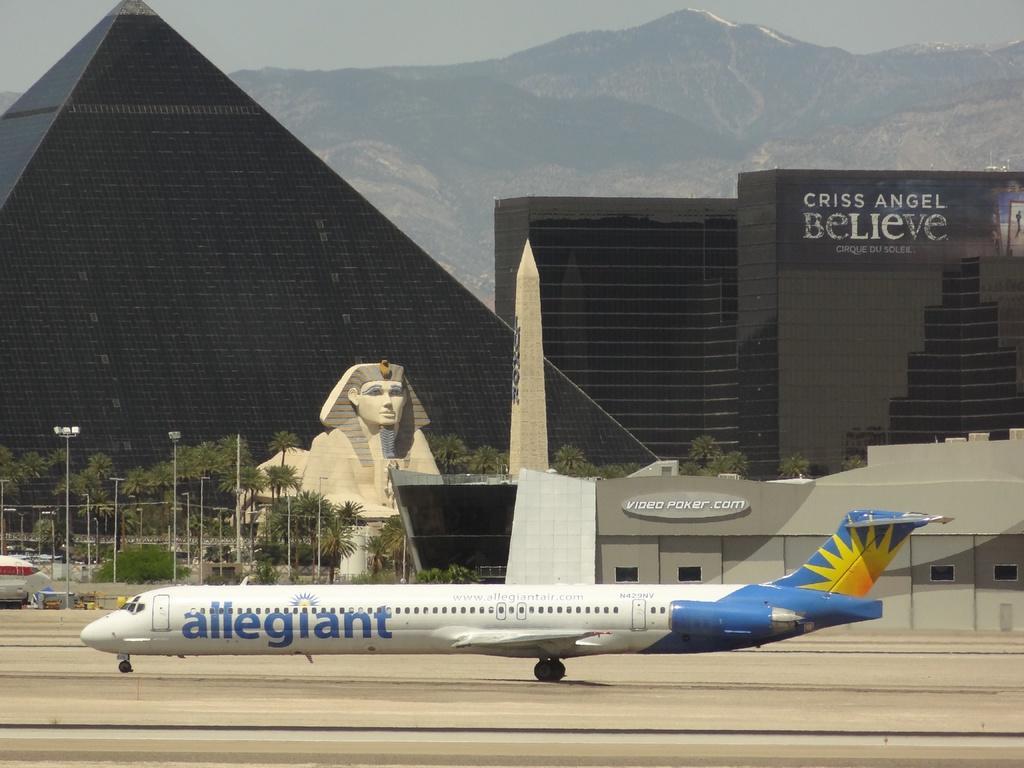Can you describe this image briefly? Here in the front we can see an airplane present on the run way over there and beside that we can see a tower and a Egyptian statue present over there and we can see light posts and plants and trees all over there and we can see buildings and a building in pyramid shaped present over there and in the far we can see mountains present all over there. 